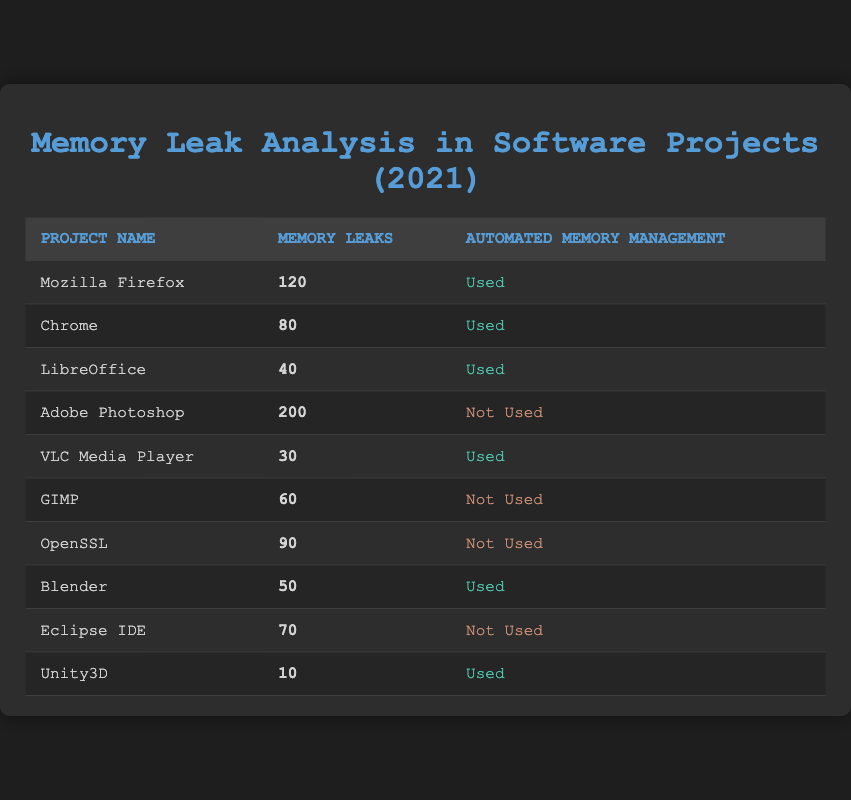What is the total number of memory leaks reported for projects that used automated memory management? From the table, the projects that used automated memory management are Mozilla Firefox (120), Chrome (80), LibreOffice (40), VLC Media Player (30), Blender (50), and Unity3D (10). Adding these values gives: 120 + 80 + 40 + 30 + 50 + 10 = 330.
Answer: 330 Which project had the highest memory leak occurrences? By inspecting the memory leaks column, Adobe Photoshop has the highest number with 200.
Answer: Adobe Photoshop What percentage of projects used automated memory management? There are 10 total projects listed. 6 of them used automated memory management. The percentage is calculated as (6/10) * 100 = 60%.
Answer: 60% Is it true that all projects not using automated memory management reported memory leaks above 50? Looking at the projects that did not use automated memory management: GIMP (60), OpenSSL (90), and Eclipse IDE (70) all reported above 50 memory leaks. Hence, it is true.
Answer: Yes What is the average number of memory leaks for projects that did not use automated memory management? The projects that did not use automated memory management and their leaks are: GIMP (60), OpenSSL (90), Eclipse IDE (70), and Adobe Photoshop (200). First, sum these values: 60 + 90 + 70 + 200 = 420. There are 4 projects, so the average is 420 / 4 = 105.
Answer: 105 How many projects had less than 50 memory leaks? By checking the memory leaks column, the projects with less than 50 leaks are VLC Media Player (30) and Unity3D (10), making a total of 2 projects.
Answer: 2 What is the difference in memory leaks between the project with the highest and the lowest occurrences among those using automated memory management? From the table, the project with the highest memory leaks (Mozilla Firefox with 120) and the lowest (Unity3D with 10). The difference is calculated as 120 - 10 = 110.
Answer: 110 How many total memory leaks were reported across all projects? Summing up all reported memory leaks: 120 + 80 + 40 + 200 + 30 + 60 + 90 + 50 + 70 + 10 = 450.
Answer: 450 